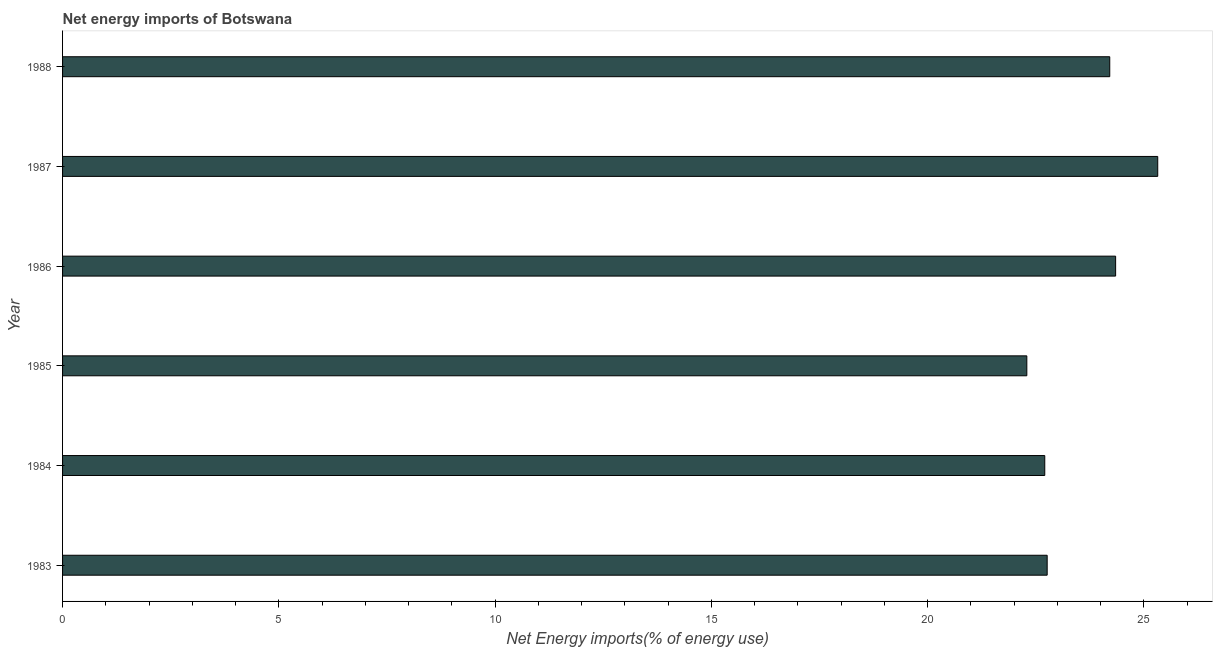Does the graph contain grids?
Your answer should be compact. No. What is the title of the graph?
Provide a succinct answer. Net energy imports of Botswana. What is the label or title of the X-axis?
Provide a succinct answer. Net Energy imports(% of energy use). What is the label or title of the Y-axis?
Your answer should be compact. Year. What is the energy imports in 1985?
Provide a short and direct response. 22.29. Across all years, what is the maximum energy imports?
Ensure brevity in your answer.  25.32. Across all years, what is the minimum energy imports?
Give a very brief answer. 22.29. What is the sum of the energy imports?
Your answer should be compact. 141.64. What is the difference between the energy imports in 1986 and 1988?
Provide a succinct answer. 0.14. What is the average energy imports per year?
Your answer should be very brief. 23.61. What is the median energy imports?
Your response must be concise. 23.49. Do a majority of the years between 1986 and 1988 (inclusive) have energy imports greater than 4 %?
Offer a terse response. Yes. Is the difference between the energy imports in 1985 and 1988 greater than the difference between any two years?
Your answer should be very brief. No. Is the sum of the energy imports in 1985 and 1987 greater than the maximum energy imports across all years?
Your answer should be very brief. Yes. What is the difference between the highest and the lowest energy imports?
Keep it short and to the point. 3.03. How many bars are there?
Your response must be concise. 6. How many years are there in the graph?
Give a very brief answer. 6. What is the Net Energy imports(% of energy use) of 1983?
Offer a very short reply. 22.76. What is the Net Energy imports(% of energy use) in 1984?
Make the answer very short. 22.71. What is the Net Energy imports(% of energy use) in 1985?
Offer a very short reply. 22.29. What is the Net Energy imports(% of energy use) of 1986?
Offer a very short reply. 24.35. What is the Net Energy imports(% of energy use) in 1987?
Keep it short and to the point. 25.32. What is the Net Energy imports(% of energy use) of 1988?
Give a very brief answer. 24.21. What is the difference between the Net Energy imports(% of energy use) in 1983 and 1984?
Offer a terse response. 0.06. What is the difference between the Net Energy imports(% of energy use) in 1983 and 1985?
Your answer should be very brief. 0.47. What is the difference between the Net Energy imports(% of energy use) in 1983 and 1986?
Your answer should be compact. -1.58. What is the difference between the Net Energy imports(% of energy use) in 1983 and 1987?
Your answer should be very brief. -2.56. What is the difference between the Net Energy imports(% of energy use) in 1983 and 1988?
Your response must be concise. -1.45. What is the difference between the Net Energy imports(% of energy use) in 1984 and 1985?
Ensure brevity in your answer.  0.41. What is the difference between the Net Energy imports(% of energy use) in 1984 and 1986?
Offer a terse response. -1.64. What is the difference between the Net Energy imports(% of energy use) in 1984 and 1987?
Offer a terse response. -2.61. What is the difference between the Net Energy imports(% of energy use) in 1984 and 1988?
Your answer should be very brief. -1.5. What is the difference between the Net Energy imports(% of energy use) in 1985 and 1986?
Keep it short and to the point. -2.05. What is the difference between the Net Energy imports(% of energy use) in 1985 and 1987?
Ensure brevity in your answer.  -3.03. What is the difference between the Net Energy imports(% of energy use) in 1985 and 1988?
Keep it short and to the point. -1.92. What is the difference between the Net Energy imports(% of energy use) in 1986 and 1987?
Your response must be concise. -0.97. What is the difference between the Net Energy imports(% of energy use) in 1986 and 1988?
Your answer should be very brief. 0.14. What is the difference between the Net Energy imports(% of energy use) in 1987 and 1988?
Ensure brevity in your answer.  1.11. What is the ratio of the Net Energy imports(% of energy use) in 1983 to that in 1984?
Provide a short and direct response. 1. What is the ratio of the Net Energy imports(% of energy use) in 1983 to that in 1986?
Keep it short and to the point. 0.94. What is the ratio of the Net Energy imports(% of energy use) in 1983 to that in 1987?
Keep it short and to the point. 0.9. What is the ratio of the Net Energy imports(% of energy use) in 1984 to that in 1985?
Offer a very short reply. 1.02. What is the ratio of the Net Energy imports(% of energy use) in 1984 to that in 1986?
Your response must be concise. 0.93. What is the ratio of the Net Energy imports(% of energy use) in 1984 to that in 1987?
Give a very brief answer. 0.9. What is the ratio of the Net Energy imports(% of energy use) in 1984 to that in 1988?
Offer a very short reply. 0.94. What is the ratio of the Net Energy imports(% of energy use) in 1985 to that in 1986?
Your answer should be compact. 0.92. What is the ratio of the Net Energy imports(% of energy use) in 1985 to that in 1988?
Keep it short and to the point. 0.92. What is the ratio of the Net Energy imports(% of energy use) in 1986 to that in 1987?
Offer a very short reply. 0.96. What is the ratio of the Net Energy imports(% of energy use) in 1986 to that in 1988?
Make the answer very short. 1.01. What is the ratio of the Net Energy imports(% of energy use) in 1987 to that in 1988?
Keep it short and to the point. 1.05. 